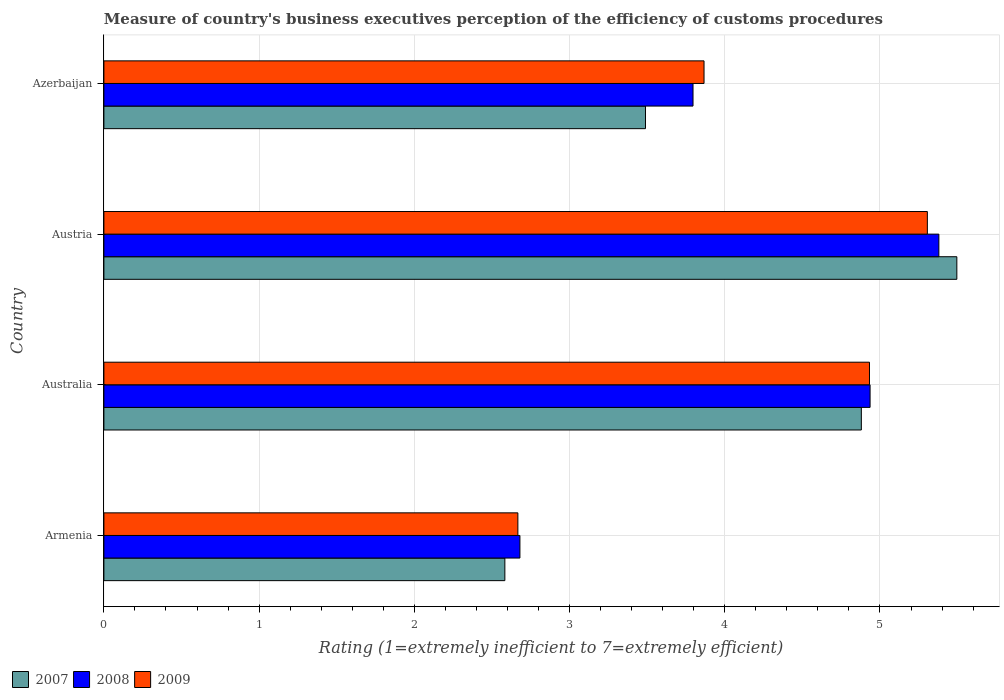How many groups of bars are there?
Your answer should be compact. 4. Are the number of bars on each tick of the Y-axis equal?
Offer a very short reply. Yes. What is the rating of the efficiency of customs procedure in 2007 in Azerbaijan?
Offer a terse response. 3.49. Across all countries, what is the maximum rating of the efficiency of customs procedure in 2007?
Your answer should be very brief. 5.5. Across all countries, what is the minimum rating of the efficiency of customs procedure in 2009?
Make the answer very short. 2.67. In which country was the rating of the efficiency of customs procedure in 2007 minimum?
Ensure brevity in your answer.  Armenia. What is the total rating of the efficiency of customs procedure in 2009 in the graph?
Offer a very short reply. 16.77. What is the difference between the rating of the efficiency of customs procedure in 2008 in Armenia and that in Azerbaijan?
Your response must be concise. -1.12. What is the difference between the rating of the efficiency of customs procedure in 2009 in Armenia and the rating of the efficiency of customs procedure in 2008 in Austria?
Your answer should be compact. -2.71. What is the average rating of the efficiency of customs procedure in 2008 per country?
Keep it short and to the point. 4.2. What is the difference between the rating of the efficiency of customs procedure in 2008 and rating of the efficiency of customs procedure in 2009 in Armenia?
Your response must be concise. 0.01. In how many countries, is the rating of the efficiency of customs procedure in 2007 greater than 1.4 ?
Offer a terse response. 4. What is the ratio of the rating of the efficiency of customs procedure in 2009 in Australia to that in Austria?
Give a very brief answer. 0.93. Is the rating of the efficiency of customs procedure in 2009 in Armenia less than that in Australia?
Give a very brief answer. Yes. What is the difference between the highest and the second highest rating of the efficiency of customs procedure in 2009?
Your answer should be very brief. 0.37. What is the difference between the highest and the lowest rating of the efficiency of customs procedure in 2007?
Your response must be concise. 2.91. In how many countries, is the rating of the efficiency of customs procedure in 2007 greater than the average rating of the efficiency of customs procedure in 2007 taken over all countries?
Ensure brevity in your answer.  2. Is the sum of the rating of the efficiency of customs procedure in 2008 in Australia and Azerbaijan greater than the maximum rating of the efficiency of customs procedure in 2007 across all countries?
Your answer should be compact. Yes. What does the 3rd bar from the top in Austria represents?
Ensure brevity in your answer.  2007. How many countries are there in the graph?
Make the answer very short. 4. Are the values on the major ticks of X-axis written in scientific E-notation?
Your response must be concise. No. Does the graph contain any zero values?
Offer a very short reply. No. Does the graph contain grids?
Your answer should be compact. Yes. Where does the legend appear in the graph?
Offer a very short reply. Bottom left. How many legend labels are there?
Keep it short and to the point. 3. How are the legend labels stacked?
Your answer should be compact. Horizontal. What is the title of the graph?
Your answer should be compact. Measure of country's business executives perception of the efficiency of customs procedures. Does "1967" appear as one of the legend labels in the graph?
Ensure brevity in your answer.  No. What is the label or title of the X-axis?
Provide a succinct answer. Rating (1=extremely inefficient to 7=extremely efficient). What is the label or title of the Y-axis?
Make the answer very short. Country. What is the Rating (1=extremely inefficient to 7=extremely efficient) of 2007 in Armenia?
Give a very brief answer. 2.58. What is the Rating (1=extremely inefficient to 7=extremely efficient) of 2008 in Armenia?
Your answer should be very brief. 2.68. What is the Rating (1=extremely inefficient to 7=extremely efficient) in 2009 in Armenia?
Provide a short and direct response. 2.67. What is the Rating (1=extremely inefficient to 7=extremely efficient) in 2007 in Australia?
Give a very brief answer. 4.88. What is the Rating (1=extremely inefficient to 7=extremely efficient) in 2008 in Australia?
Offer a terse response. 4.94. What is the Rating (1=extremely inefficient to 7=extremely efficient) of 2009 in Australia?
Provide a succinct answer. 4.93. What is the Rating (1=extremely inefficient to 7=extremely efficient) in 2007 in Austria?
Keep it short and to the point. 5.5. What is the Rating (1=extremely inefficient to 7=extremely efficient) of 2008 in Austria?
Provide a short and direct response. 5.38. What is the Rating (1=extremely inefficient to 7=extremely efficient) of 2009 in Austria?
Your response must be concise. 5.31. What is the Rating (1=extremely inefficient to 7=extremely efficient) in 2007 in Azerbaijan?
Offer a very short reply. 3.49. What is the Rating (1=extremely inefficient to 7=extremely efficient) in 2008 in Azerbaijan?
Keep it short and to the point. 3.8. What is the Rating (1=extremely inefficient to 7=extremely efficient) in 2009 in Azerbaijan?
Your answer should be compact. 3.87. Across all countries, what is the maximum Rating (1=extremely inefficient to 7=extremely efficient) of 2007?
Your answer should be compact. 5.5. Across all countries, what is the maximum Rating (1=extremely inefficient to 7=extremely efficient) of 2008?
Your answer should be compact. 5.38. Across all countries, what is the maximum Rating (1=extremely inefficient to 7=extremely efficient) of 2009?
Make the answer very short. 5.31. Across all countries, what is the minimum Rating (1=extremely inefficient to 7=extremely efficient) in 2007?
Offer a terse response. 2.58. Across all countries, what is the minimum Rating (1=extremely inefficient to 7=extremely efficient) in 2008?
Provide a succinct answer. 2.68. Across all countries, what is the minimum Rating (1=extremely inefficient to 7=extremely efficient) of 2009?
Your answer should be compact. 2.67. What is the total Rating (1=extremely inefficient to 7=extremely efficient) of 2007 in the graph?
Ensure brevity in your answer.  16.45. What is the total Rating (1=extremely inefficient to 7=extremely efficient) in 2008 in the graph?
Provide a succinct answer. 16.79. What is the total Rating (1=extremely inefficient to 7=extremely efficient) of 2009 in the graph?
Offer a terse response. 16.77. What is the difference between the Rating (1=extremely inefficient to 7=extremely efficient) in 2007 in Armenia and that in Australia?
Your answer should be very brief. -2.3. What is the difference between the Rating (1=extremely inefficient to 7=extremely efficient) in 2008 in Armenia and that in Australia?
Ensure brevity in your answer.  -2.26. What is the difference between the Rating (1=extremely inefficient to 7=extremely efficient) in 2009 in Armenia and that in Australia?
Provide a succinct answer. -2.27. What is the difference between the Rating (1=extremely inefficient to 7=extremely efficient) of 2007 in Armenia and that in Austria?
Offer a very short reply. -2.91. What is the difference between the Rating (1=extremely inefficient to 7=extremely efficient) of 2008 in Armenia and that in Austria?
Offer a very short reply. -2.7. What is the difference between the Rating (1=extremely inefficient to 7=extremely efficient) of 2009 in Armenia and that in Austria?
Offer a terse response. -2.64. What is the difference between the Rating (1=extremely inefficient to 7=extremely efficient) of 2007 in Armenia and that in Azerbaijan?
Provide a short and direct response. -0.91. What is the difference between the Rating (1=extremely inefficient to 7=extremely efficient) in 2008 in Armenia and that in Azerbaijan?
Your answer should be compact. -1.12. What is the difference between the Rating (1=extremely inefficient to 7=extremely efficient) of 2009 in Armenia and that in Azerbaijan?
Your response must be concise. -1.2. What is the difference between the Rating (1=extremely inefficient to 7=extremely efficient) in 2007 in Australia and that in Austria?
Give a very brief answer. -0.62. What is the difference between the Rating (1=extremely inefficient to 7=extremely efficient) of 2008 in Australia and that in Austria?
Provide a short and direct response. -0.44. What is the difference between the Rating (1=extremely inefficient to 7=extremely efficient) in 2009 in Australia and that in Austria?
Provide a succinct answer. -0.37. What is the difference between the Rating (1=extremely inefficient to 7=extremely efficient) of 2007 in Australia and that in Azerbaijan?
Provide a succinct answer. 1.39. What is the difference between the Rating (1=extremely inefficient to 7=extremely efficient) of 2008 in Australia and that in Azerbaijan?
Your response must be concise. 1.14. What is the difference between the Rating (1=extremely inefficient to 7=extremely efficient) of 2009 in Australia and that in Azerbaijan?
Provide a short and direct response. 1.07. What is the difference between the Rating (1=extremely inefficient to 7=extremely efficient) of 2007 in Austria and that in Azerbaijan?
Offer a very short reply. 2.01. What is the difference between the Rating (1=extremely inefficient to 7=extremely efficient) of 2008 in Austria and that in Azerbaijan?
Offer a terse response. 1.58. What is the difference between the Rating (1=extremely inefficient to 7=extremely efficient) of 2009 in Austria and that in Azerbaijan?
Your answer should be compact. 1.44. What is the difference between the Rating (1=extremely inefficient to 7=extremely efficient) of 2007 in Armenia and the Rating (1=extremely inefficient to 7=extremely efficient) of 2008 in Australia?
Offer a terse response. -2.35. What is the difference between the Rating (1=extremely inefficient to 7=extremely efficient) in 2007 in Armenia and the Rating (1=extremely inefficient to 7=extremely efficient) in 2009 in Australia?
Provide a succinct answer. -2.35. What is the difference between the Rating (1=extremely inefficient to 7=extremely efficient) of 2008 in Armenia and the Rating (1=extremely inefficient to 7=extremely efficient) of 2009 in Australia?
Offer a terse response. -2.25. What is the difference between the Rating (1=extremely inefficient to 7=extremely efficient) in 2007 in Armenia and the Rating (1=extremely inefficient to 7=extremely efficient) in 2008 in Austria?
Ensure brevity in your answer.  -2.8. What is the difference between the Rating (1=extremely inefficient to 7=extremely efficient) in 2007 in Armenia and the Rating (1=extremely inefficient to 7=extremely efficient) in 2009 in Austria?
Ensure brevity in your answer.  -2.72. What is the difference between the Rating (1=extremely inefficient to 7=extremely efficient) of 2008 in Armenia and the Rating (1=extremely inefficient to 7=extremely efficient) of 2009 in Austria?
Your answer should be compact. -2.62. What is the difference between the Rating (1=extremely inefficient to 7=extremely efficient) in 2007 in Armenia and the Rating (1=extremely inefficient to 7=extremely efficient) in 2008 in Azerbaijan?
Offer a very short reply. -1.21. What is the difference between the Rating (1=extremely inefficient to 7=extremely efficient) in 2007 in Armenia and the Rating (1=extremely inefficient to 7=extremely efficient) in 2009 in Azerbaijan?
Give a very brief answer. -1.28. What is the difference between the Rating (1=extremely inefficient to 7=extremely efficient) of 2008 in Armenia and the Rating (1=extremely inefficient to 7=extremely efficient) of 2009 in Azerbaijan?
Provide a short and direct response. -1.19. What is the difference between the Rating (1=extremely inefficient to 7=extremely efficient) of 2007 in Australia and the Rating (1=extremely inefficient to 7=extremely efficient) of 2008 in Austria?
Provide a succinct answer. -0.5. What is the difference between the Rating (1=extremely inefficient to 7=extremely efficient) of 2007 in Australia and the Rating (1=extremely inefficient to 7=extremely efficient) of 2009 in Austria?
Offer a very short reply. -0.43. What is the difference between the Rating (1=extremely inefficient to 7=extremely efficient) in 2008 in Australia and the Rating (1=extremely inefficient to 7=extremely efficient) in 2009 in Austria?
Give a very brief answer. -0.37. What is the difference between the Rating (1=extremely inefficient to 7=extremely efficient) in 2007 in Australia and the Rating (1=extremely inefficient to 7=extremely efficient) in 2008 in Azerbaijan?
Keep it short and to the point. 1.08. What is the difference between the Rating (1=extremely inefficient to 7=extremely efficient) of 2007 in Australia and the Rating (1=extremely inefficient to 7=extremely efficient) of 2009 in Azerbaijan?
Your response must be concise. 1.01. What is the difference between the Rating (1=extremely inefficient to 7=extremely efficient) of 2008 in Australia and the Rating (1=extremely inefficient to 7=extremely efficient) of 2009 in Azerbaijan?
Offer a very short reply. 1.07. What is the difference between the Rating (1=extremely inefficient to 7=extremely efficient) of 2007 in Austria and the Rating (1=extremely inefficient to 7=extremely efficient) of 2008 in Azerbaijan?
Give a very brief answer. 1.7. What is the difference between the Rating (1=extremely inefficient to 7=extremely efficient) in 2007 in Austria and the Rating (1=extremely inefficient to 7=extremely efficient) in 2009 in Azerbaijan?
Your response must be concise. 1.63. What is the difference between the Rating (1=extremely inefficient to 7=extremely efficient) of 2008 in Austria and the Rating (1=extremely inefficient to 7=extremely efficient) of 2009 in Azerbaijan?
Your response must be concise. 1.51. What is the average Rating (1=extremely inefficient to 7=extremely efficient) in 2007 per country?
Provide a short and direct response. 4.11. What is the average Rating (1=extremely inefficient to 7=extremely efficient) of 2008 per country?
Your answer should be compact. 4.2. What is the average Rating (1=extremely inefficient to 7=extremely efficient) of 2009 per country?
Offer a terse response. 4.19. What is the difference between the Rating (1=extremely inefficient to 7=extremely efficient) of 2007 and Rating (1=extremely inefficient to 7=extremely efficient) of 2008 in Armenia?
Your answer should be compact. -0.1. What is the difference between the Rating (1=extremely inefficient to 7=extremely efficient) in 2007 and Rating (1=extremely inefficient to 7=extremely efficient) in 2009 in Armenia?
Provide a short and direct response. -0.08. What is the difference between the Rating (1=extremely inefficient to 7=extremely efficient) in 2008 and Rating (1=extremely inefficient to 7=extremely efficient) in 2009 in Armenia?
Offer a terse response. 0.01. What is the difference between the Rating (1=extremely inefficient to 7=extremely efficient) in 2007 and Rating (1=extremely inefficient to 7=extremely efficient) in 2008 in Australia?
Make the answer very short. -0.06. What is the difference between the Rating (1=extremely inefficient to 7=extremely efficient) of 2007 and Rating (1=extremely inefficient to 7=extremely efficient) of 2009 in Australia?
Your response must be concise. -0.05. What is the difference between the Rating (1=extremely inefficient to 7=extremely efficient) of 2008 and Rating (1=extremely inefficient to 7=extremely efficient) of 2009 in Australia?
Ensure brevity in your answer.  0. What is the difference between the Rating (1=extremely inefficient to 7=extremely efficient) of 2007 and Rating (1=extremely inefficient to 7=extremely efficient) of 2008 in Austria?
Your answer should be compact. 0.12. What is the difference between the Rating (1=extremely inefficient to 7=extremely efficient) in 2007 and Rating (1=extremely inefficient to 7=extremely efficient) in 2009 in Austria?
Keep it short and to the point. 0.19. What is the difference between the Rating (1=extremely inefficient to 7=extremely efficient) in 2008 and Rating (1=extremely inefficient to 7=extremely efficient) in 2009 in Austria?
Keep it short and to the point. 0.07. What is the difference between the Rating (1=extremely inefficient to 7=extremely efficient) in 2007 and Rating (1=extremely inefficient to 7=extremely efficient) in 2008 in Azerbaijan?
Make the answer very short. -0.31. What is the difference between the Rating (1=extremely inefficient to 7=extremely efficient) in 2007 and Rating (1=extremely inefficient to 7=extremely efficient) in 2009 in Azerbaijan?
Your answer should be very brief. -0.38. What is the difference between the Rating (1=extremely inefficient to 7=extremely efficient) in 2008 and Rating (1=extremely inefficient to 7=extremely efficient) in 2009 in Azerbaijan?
Make the answer very short. -0.07. What is the ratio of the Rating (1=extremely inefficient to 7=extremely efficient) of 2007 in Armenia to that in Australia?
Your answer should be very brief. 0.53. What is the ratio of the Rating (1=extremely inefficient to 7=extremely efficient) of 2008 in Armenia to that in Australia?
Keep it short and to the point. 0.54. What is the ratio of the Rating (1=extremely inefficient to 7=extremely efficient) of 2009 in Armenia to that in Australia?
Offer a very short reply. 0.54. What is the ratio of the Rating (1=extremely inefficient to 7=extremely efficient) of 2007 in Armenia to that in Austria?
Make the answer very short. 0.47. What is the ratio of the Rating (1=extremely inefficient to 7=extremely efficient) in 2008 in Armenia to that in Austria?
Make the answer very short. 0.5. What is the ratio of the Rating (1=extremely inefficient to 7=extremely efficient) of 2009 in Armenia to that in Austria?
Your answer should be compact. 0.5. What is the ratio of the Rating (1=extremely inefficient to 7=extremely efficient) of 2007 in Armenia to that in Azerbaijan?
Provide a short and direct response. 0.74. What is the ratio of the Rating (1=extremely inefficient to 7=extremely efficient) in 2008 in Armenia to that in Azerbaijan?
Provide a succinct answer. 0.71. What is the ratio of the Rating (1=extremely inefficient to 7=extremely efficient) in 2009 in Armenia to that in Azerbaijan?
Offer a very short reply. 0.69. What is the ratio of the Rating (1=extremely inefficient to 7=extremely efficient) of 2007 in Australia to that in Austria?
Provide a succinct answer. 0.89. What is the ratio of the Rating (1=extremely inefficient to 7=extremely efficient) in 2008 in Australia to that in Austria?
Provide a short and direct response. 0.92. What is the ratio of the Rating (1=extremely inefficient to 7=extremely efficient) of 2009 in Australia to that in Austria?
Give a very brief answer. 0.93. What is the ratio of the Rating (1=extremely inefficient to 7=extremely efficient) in 2007 in Australia to that in Azerbaijan?
Ensure brevity in your answer.  1.4. What is the ratio of the Rating (1=extremely inefficient to 7=extremely efficient) of 2008 in Australia to that in Azerbaijan?
Keep it short and to the point. 1.3. What is the ratio of the Rating (1=extremely inefficient to 7=extremely efficient) in 2009 in Australia to that in Azerbaijan?
Keep it short and to the point. 1.28. What is the ratio of the Rating (1=extremely inefficient to 7=extremely efficient) in 2007 in Austria to that in Azerbaijan?
Offer a very short reply. 1.57. What is the ratio of the Rating (1=extremely inefficient to 7=extremely efficient) of 2008 in Austria to that in Azerbaijan?
Your answer should be very brief. 1.42. What is the ratio of the Rating (1=extremely inefficient to 7=extremely efficient) in 2009 in Austria to that in Azerbaijan?
Offer a terse response. 1.37. What is the difference between the highest and the second highest Rating (1=extremely inefficient to 7=extremely efficient) of 2007?
Give a very brief answer. 0.62. What is the difference between the highest and the second highest Rating (1=extremely inefficient to 7=extremely efficient) of 2008?
Ensure brevity in your answer.  0.44. What is the difference between the highest and the second highest Rating (1=extremely inefficient to 7=extremely efficient) in 2009?
Make the answer very short. 0.37. What is the difference between the highest and the lowest Rating (1=extremely inefficient to 7=extremely efficient) of 2007?
Your answer should be compact. 2.91. What is the difference between the highest and the lowest Rating (1=extremely inefficient to 7=extremely efficient) in 2008?
Your answer should be very brief. 2.7. What is the difference between the highest and the lowest Rating (1=extremely inefficient to 7=extremely efficient) in 2009?
Ensure brevity in your answer.  2.64. 